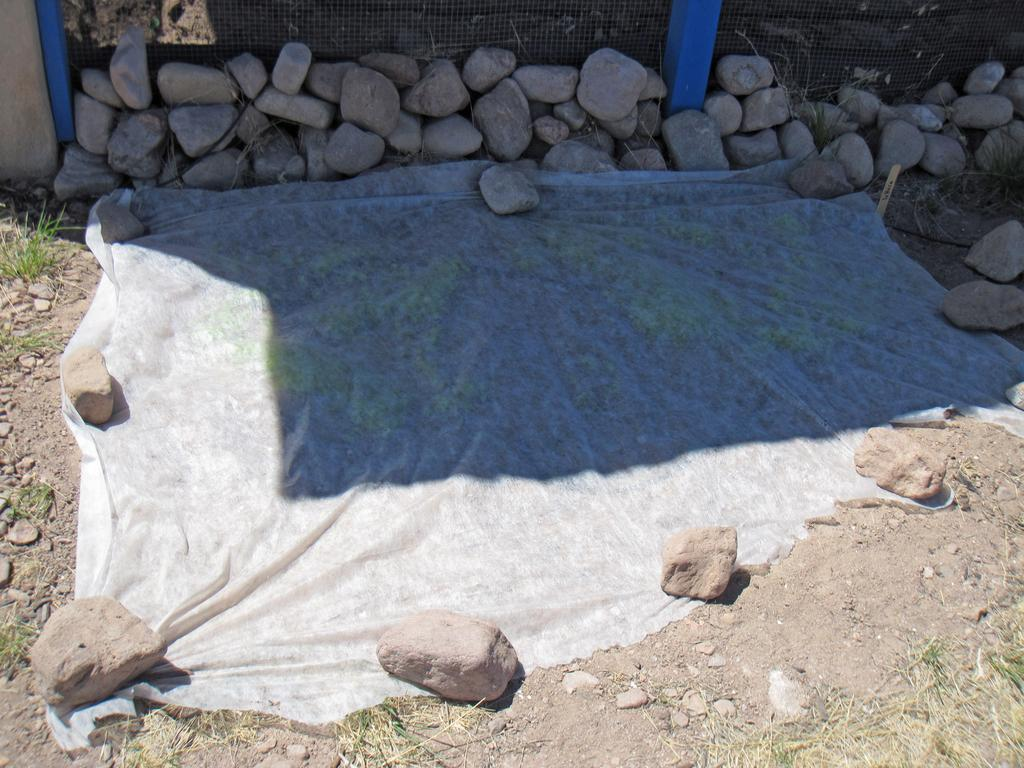What is covering the ground in the image? There is a cloth on the ground in the image. What type of natural elements can be seen in the image? Stones and grass are visible in the image. What is in the background of the image? There is a fence in the background of the image. Where is the tent located in the image? There is no tent present in the image. What type of sea creatures can be seen swimming in the image? There is no sea or sea creatures present in the image. 